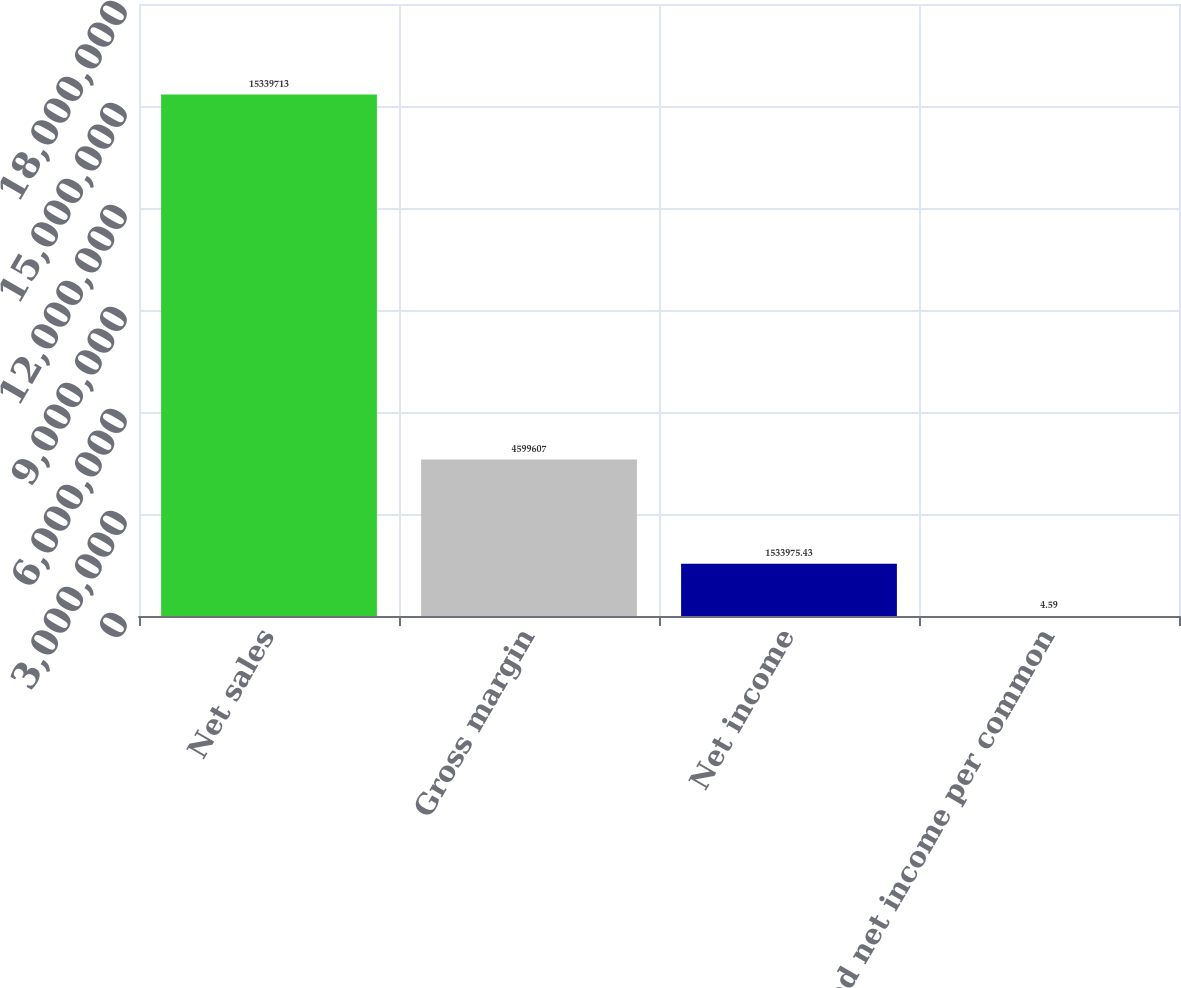Convert chart. <chart><loc_0><loc_0><loc_500><loc_500><bar_chart><fcel>Net sales<fcel>Gross margin<fcel>Net income<fcel>Diluted net income per common<nl><fcel>1.53397e+07<fcel>4.59961e+06<fcel>1.53398e+06<fcel>4.59<nl></chart> 